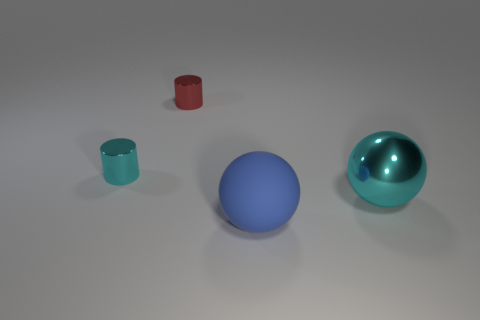Add 2 blue spheres. How many objects exist? 6 Add 4 red metal cylinders. How many red metal cylinders exist? 5 Subtract 0 gray spheres. How many objects are left? 4 Subtract all blue spheres. Subtract all yellow cylinders. How many spheres are left? 1 Subtract all brown blocks. How many cyan balls are left? 1 Subtract all green metallic blocks. Subtract all big balls. How many objects are left? 2 Add 3 blue balls. How many blue balls are left? 4 